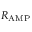Convert formula to latex. <formula><loc_0><loc_0><loc_500><loc_500>R _ { A M P }</formula> 